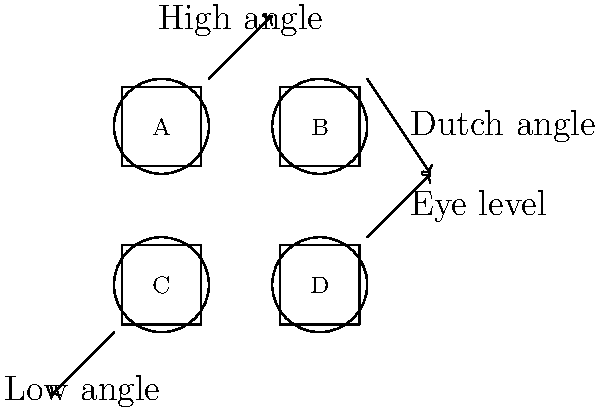As a showrunner, you're reviewing storyboard sketches for a pivotal scene. Which camera angle would best capture the protagonist's vulnerability while maintaining visual interest, considering the network's preference for conventional shots? To answer this question, let's analyze each camera angle presented in the storyboard sketches:

1. Sketch A (High angle): This angle looks down on the subject, making them appear smaller or weaker. It can effectively convey vulnerability but might be too obvious or heavy-handed.

2. Sketch B (Dutch angle): This tilted angle creates a sense of disorientation or unease. While visually interesting, it might be too avant-garde for the network's conventional preferences.

3. Sketch C (Low angle): This angle looks up at the subject, typically making them appear powerful or dominant. It's not suitable for conveying vulnerability.

4. Sketch D (Eye level): This is a neutral, conventional angle that puts the viewer on equal footing with the subject. While it may not be the most dramatic choice, it can subtly convey vulnerability through the actor's performance and composition.

Considering the need to capture the protagonist's vulnerability while maintaining visual interest and appeasing the network's preference for conventional shots, the eye level angle (Sketch D) is the optimal choice. It allows for a nuanced portrayal of vulnerability through performance and framing without resorting to more obvious or unconventional techniques that might clash with the network's expectations.
Answer: Eye level (Sketch D) 